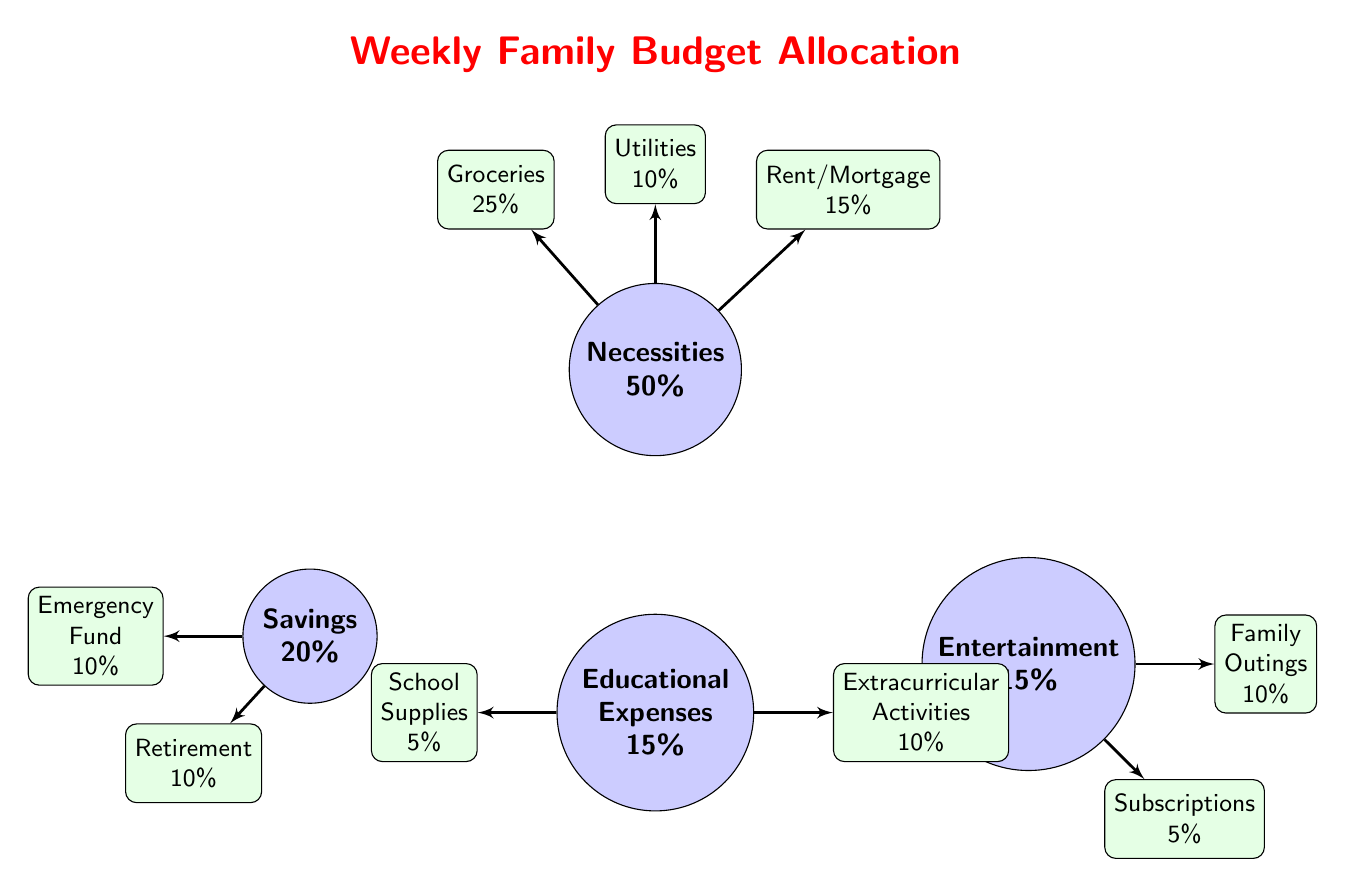What percentage of the weekly budget is allocated to necessities? The main node labeled "Necessities" in the diagram shows the allocation percentage directly, which is 50%.
Answer: 50% How many sub-categories are listed under necessities? The diagram shows three sub-nodes connected to the main node "Necessities," which are Groceries, Utilities, and Rent/Mortgage.
Answer: 3 What is the total percentage allocated to educational expenses? The main node labeled "Educational Expenses" shows that this category accounts for 15% of the total budget.
Answer: 15% Which sub-category under savings has a higher percentage: Emergency Fund or Retirement? The sub-nodes under "Savings" indicate that both Emergency Fund and Retirement each allocate 10%, so they are equal.
Answer: Equal What is the combined percentage allocated to Entertainment and Education? The Entertainment category allocates 15%, and Education allocates another 15%. Adding these two percentages together gives a total of 30%.
Answer: 30% Which category has the lowest percentage allocation? In the diagram, the category with the lowest percentage is "Subscriptions" under Entertainment, which allocates only 5%.
Answer: 5% What is the percentage allocated to Extracurricular Activities? The sub-node labeled "Extracurricular Activities" under Educational Expenses shows that it accommodates 10% of the budget.
Answer: 10% What relationship do the "Rent/Mortgage" and "Utilities" nodes share? Both "Rent/Mortgage" and "Utilities" are subcategories under the main category "Necessities," indicating they are both essential expenses for the family.
Answer: Necessities What fraction of the budget is assigned to Savings? The percentage allocated to Savings is 20%, which can be represented as a fraction of 1/5 of the budget.
Answer: 20% 